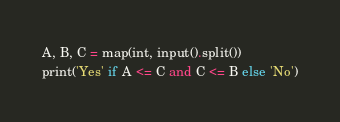Convert code to text. <code><loc_0><loc_0><loc_500><loc_500><_Python_>A, B, C = map(int, input().split())
print('Yes' if A <= C and C <= B else 'No')</code> 